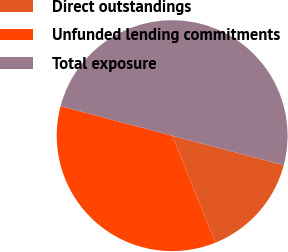Convert chart to OTSL. <chart><loc_0><loc_0><loc_500><loc_500><pie_chart><fcel>Direct outstandings<fcel>Unfunded lending commitments<fcel>Total exposure<nl><fcel>14.79%<fcel>35.21%<fcel>50.0%<nl></chart> 